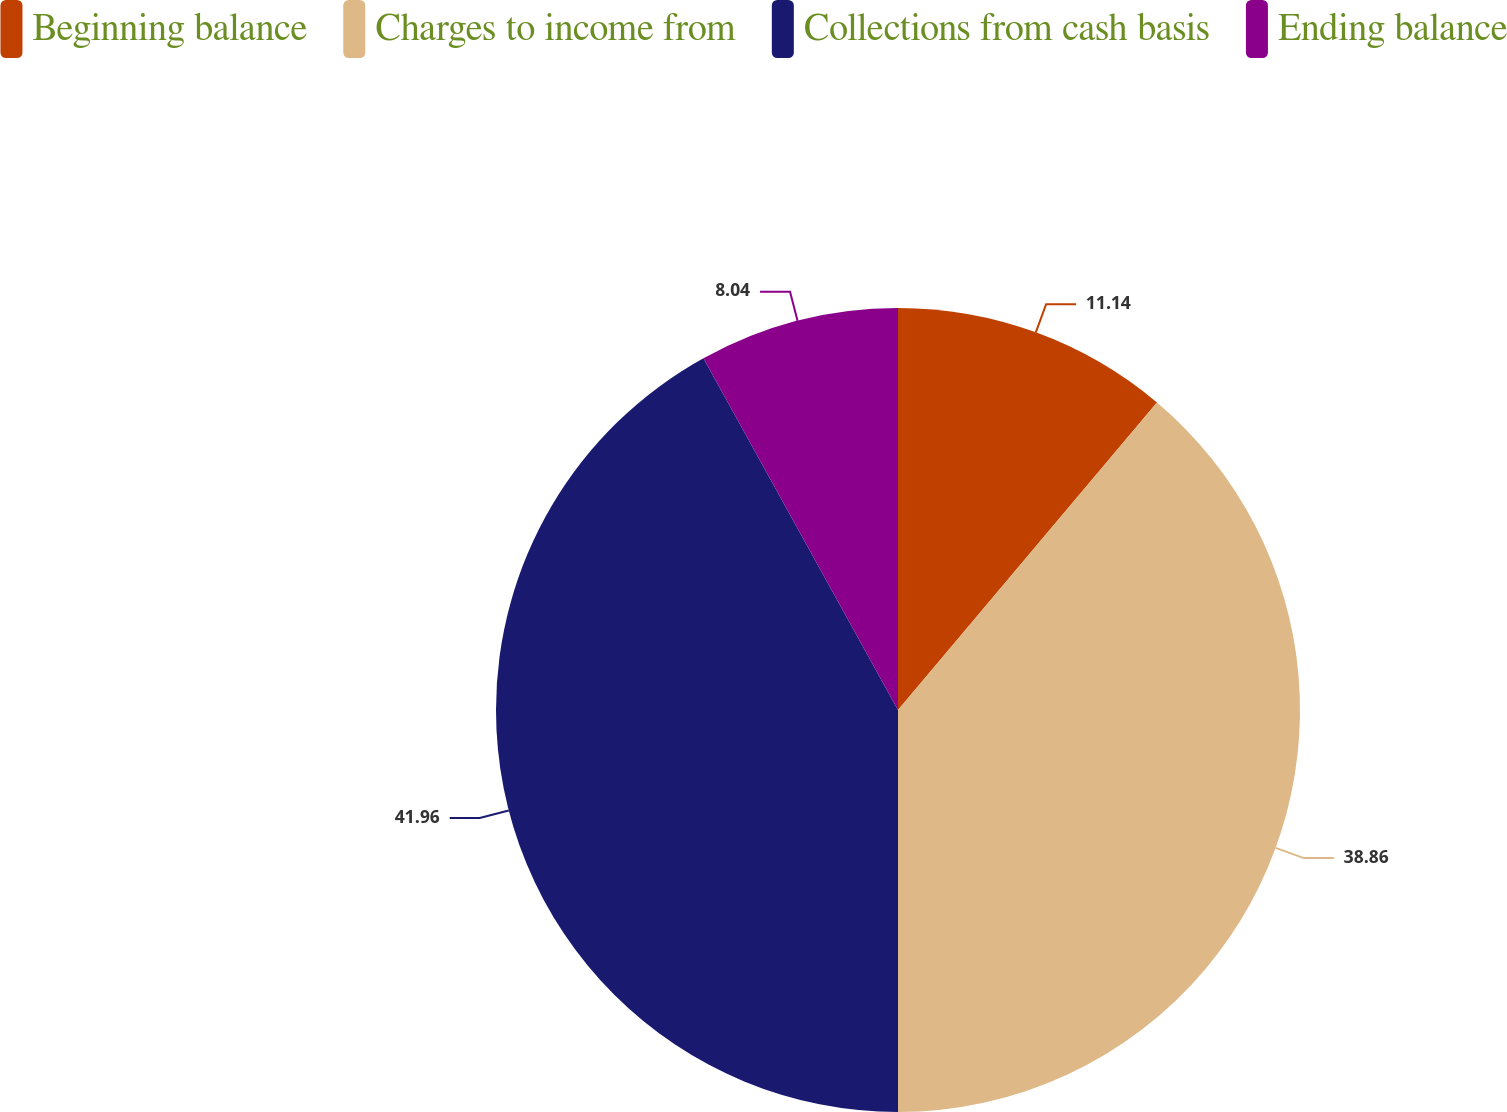Convert chart to OTSL. <chart><loc_0><loc_0><loc_500><loc_500><pie_chart><fcel>Beginning balance<fcel>Charges to income from<fcel>Collections from cash basis<fcel>Ending balance<nl><fcel>11.14%<fcel>38.86%<fcel>41.96%<fcel>8.04%<nl></chart> 